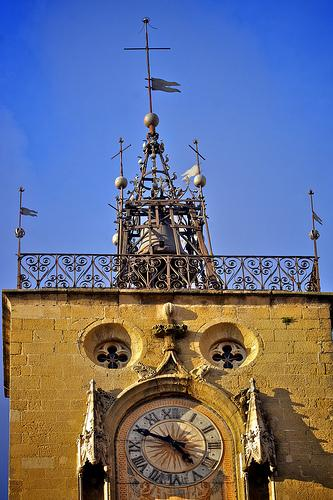What kind of decorations can be seen between the two circular windows? A statue and some cross designs can be seen between the two circular windows. What can you say about the wall in the image? The wall is brown, made of stones and bricks, and appears worn and yellow in some places. Describe the appearance of the clock present in the image. The clock is circular, white and has roman numerals with black hour and minute hands. Can you identify any architectural features on the building in the image? Fancy ornate stone work, cast iron work, circular windows, and triangular shapes near the clock. What is the primary object in the image related to time-keeping? A clock on an old building with roman numerals in a stone tower. What is the color and condition of the building in the image? The building is tan-colored and appears to have some wear, with ornate stone and cast iron work. What is the position of the clock on the building, and what do its hands indicate? The clock is on the side of the building at a 550 position, with black hour and minute hands. What can you infer from the shadows and the brightness of the sky in the image? The photo was taken in the daytime, with a clear and bright blue sky, and visible shadows of rectangular objects. Is there any religious symbol present in the image? If so, describe it. Yes, there is a large metal cross on top of the building with a flag facing right. What does the sky look like in the image? The sky is clear, bright blue, and appears to have been taken during daytime. Identify the primary material of the cross atop the tower. Metal Determine if the sky is clear or cloudy in the image. Clear Figure out the event that took place based on the objects in the image. No specific event can be concluded from the objects in the image Does the flag on the large cross face to the left? The flag is described as facing to the right (e.g. "the flag is facing right"), not facing to the left. What is the color of the sky in the image? Blue How is the flag positioned on the image? Facing right What are the major attributes of the object between the two circular windows? Decoration, size, position Is the clock on the old building square-shaped? The clock is mentioned as being circular (e.g. "the clock is circle"), not square-shaped. Identify the color of the brick on the wall in the image. Yellow and brown Identify the style of numbers used on the clock. Roman numerals Are the clock's numbers written in Arabic numerals? The clock numbers are described as being in Roman numerals (e.g. "clock numbers are in roman numerals"), not Arabic numerals. Combine the tower and the sky information into a narrative. Once upon a time, in a village with a blue, clear sky, stood an old tower adorned with Roman numerals on its clock, weathered stone, and masonry. Determine whether the railing is black or white. Black Describe the material of the wall near the clock. The wall is made of brick and stones Is the cross on top of the building made of wood? The cross is described as being made of metal (e.g. "the cross is metal"), not wood. Does the sky appear cloudy and gray in the image? No, it's not mentioned in the image. What time does the clock say, in Roman numerals? X and L Describe the clock using a vivid, imaginative phrase. A majestic ancient clock adorned with Roman numerals Write a poetic description of the tower, focusing on the stone and masonry. A venerable tower stands tall, its stonework etched with tales of time passes by, a bastion of masonry, proud and eternal. Which object is located on the left-top corner of the building? b) door What is the location of the old tower in relation to the sky in the image? Below the sky Explain the purpose of the triangular shapes near the clock. Their purpose is to serve as decorative elements on the tower and to frame the clock. Is the wall of the building painted green? The wall is described as being brown or yellow and made of stones or bricks (e.g. "the wall is brown in color", "the wall is yellow"), not green in color. Read the time shown on the clock. Five-fifty 